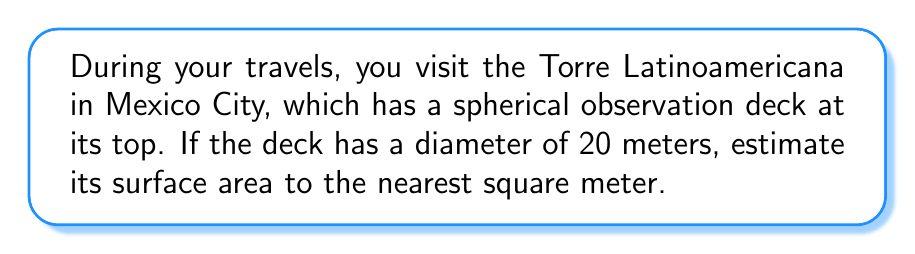Teach me how to tackle this problem. To estimate the surface area of the spherical observation deck, we'll use the formula for the surface area of a sphere:

$$A = 4\pi r^2$$

Where:
$A$ = surface area
$r$ = radius of the sphere

Step 1: Determine the radius
The diameter is given as 20 meters, so the radius is half of that:
$$r = \frac{20}{2} = 10\text{ meters}$$

Step 2: Apply the formula
$$\begin{align*}
A &= 4\pi r^2 \\
&= 4\pi (10)^2 \\
&= 4\pi (100) \\
&= 400\pi \text{ square meters}
\end{align*}$$

Step 3: Calculate the result
$$400\pi \approx 1256.64\text{ square meters}$$

Step 4: Round to the nearest square meter
$$1256.64 \approx 1257\text{ square meters}$$

[asy]
import geometry;

size(200);
draw(circle((0,0),5), rgb(0,0,1));
dot((0,0), rgb(1,0,0));
draw((0,0)--(5,0), arrow=Arrow(TeXHead));
label("$r$", (2.5,0.5));
label("Spherical Observation Deck", (0,-6));
[/asy]
Answer: 1257 m² 